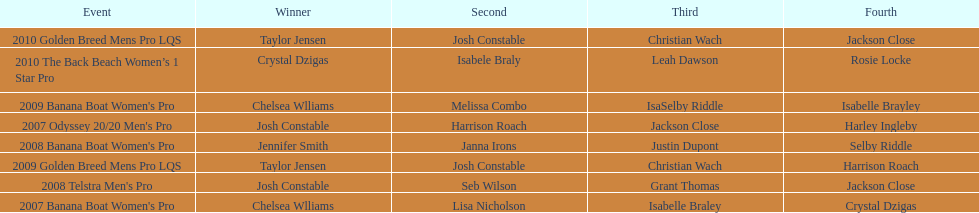What is the total number of times chelsea williams was the winner between 2007 and 2010? 2. 